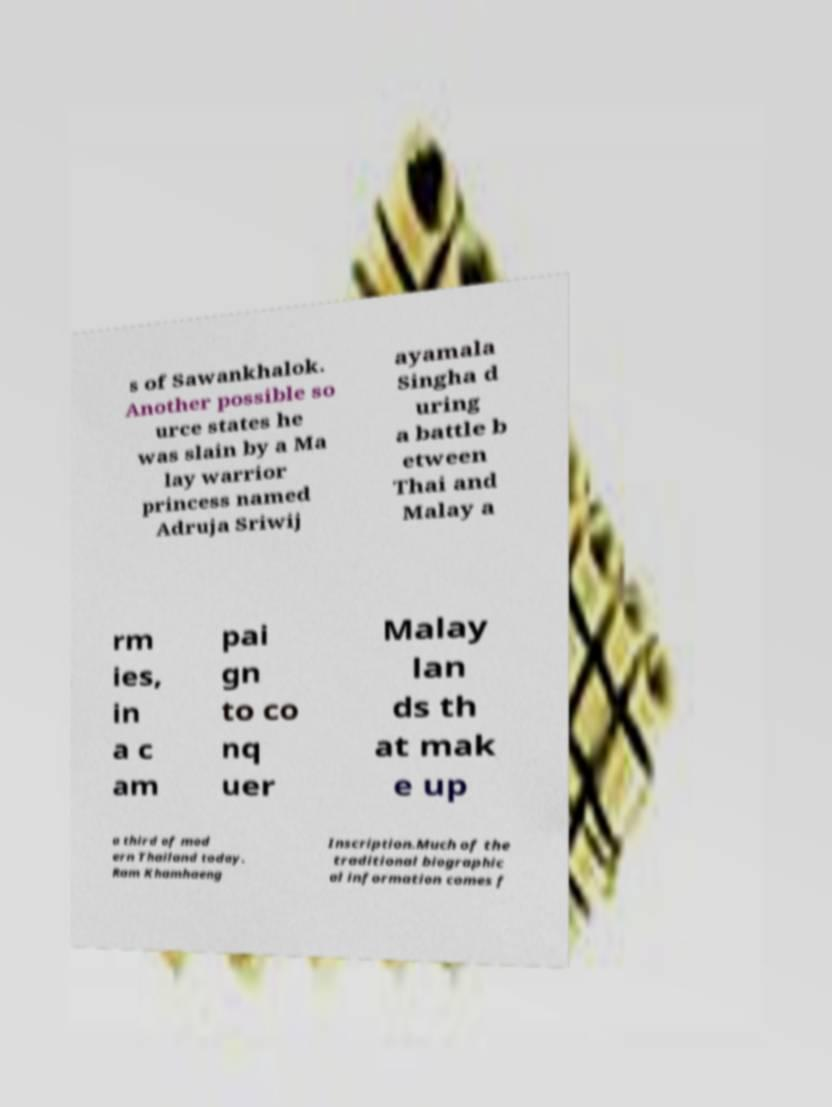What messages or text are displayed in this image? I need them in a readable, typed format. s of Sawankhalok. Another possible so urce states he was slain by a Ma lay warrior princess named Adruja Sriwij ayamala Singha d uring a battle b etween Thai and Malay a rm ies, in a c am pai gn to co nq uer Malay lan ds th at mak e up a third of mod ern Thailand today. Ram Khamhaeng Inscription.Much of the traditional biographic al information comes f 